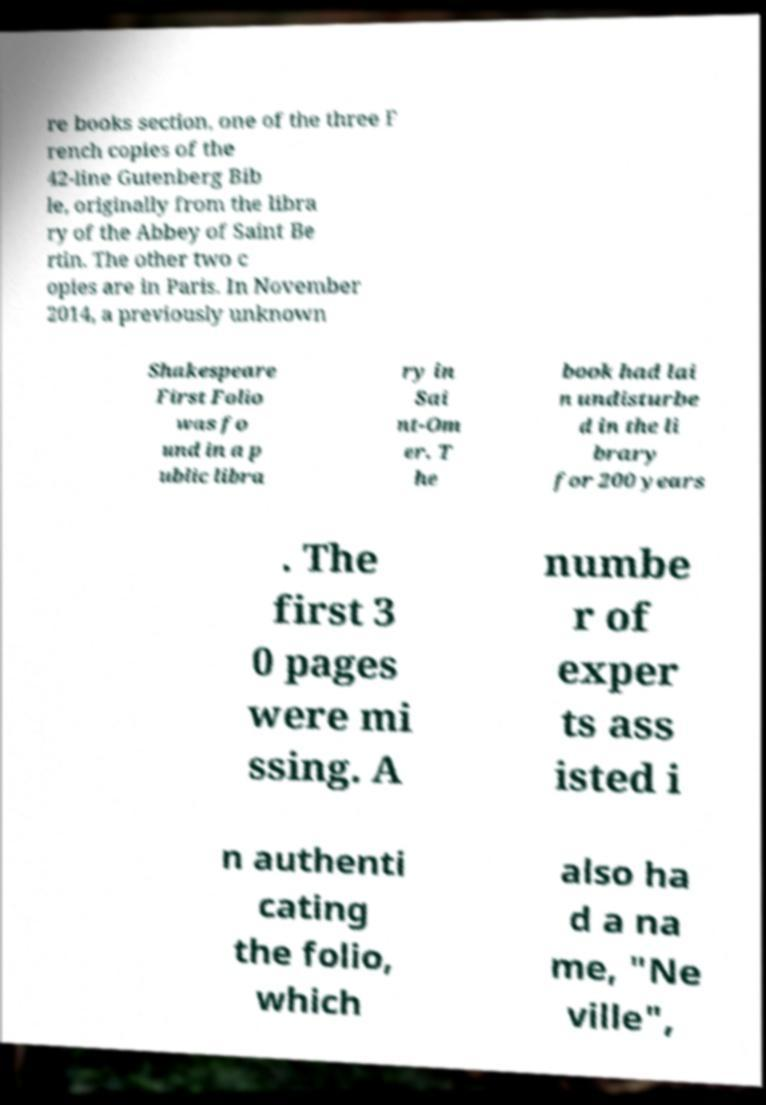Please identify and transcribe the text found in this image. re books section, one of the three F rench copies of the 42-line Gutenberg Bib le, originally from the libra ry of the Abbey of Saint Be rtin. The other two c opies are in Paris. In November 2014, a previously unknown Shakespeare First Folio was fo und in a p ublic libra ry in Sai nt-Om er. T he book had lai n undisturbe d in the li brary for 200 years . The first 3 0 pages were mi ssing. A numbe r of exper ts ass isted i n authenti cating the folio, which also ha d a na me, "Ne ville", 